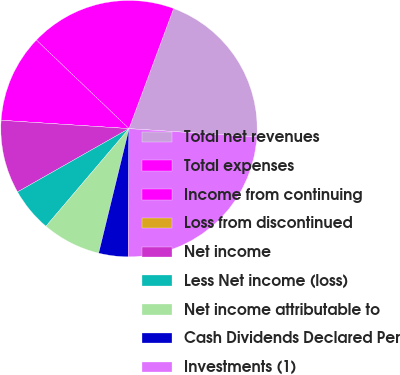<chart> <loc_0><loc_0><loc_500><loc_500><pie_chart><fcel>Total net revenues<fcel>Total expenses<fcel>Income from continuing<fcel>Loss from discontinued<fcel>Net income<fcel>Less Net income (loss)<fcel>Net income attributable to<fcel>Cash Dividends Declared Per<fcel>Investments (1)<nl><fcel>20.37%<fcel>18.52%<fcel>11.11%<fcel>0.0%<fcel>9.26%<fcel>5.56%<fcel>7.41%<fcel>3.7%<fcel>24.07%<nl></chart> 